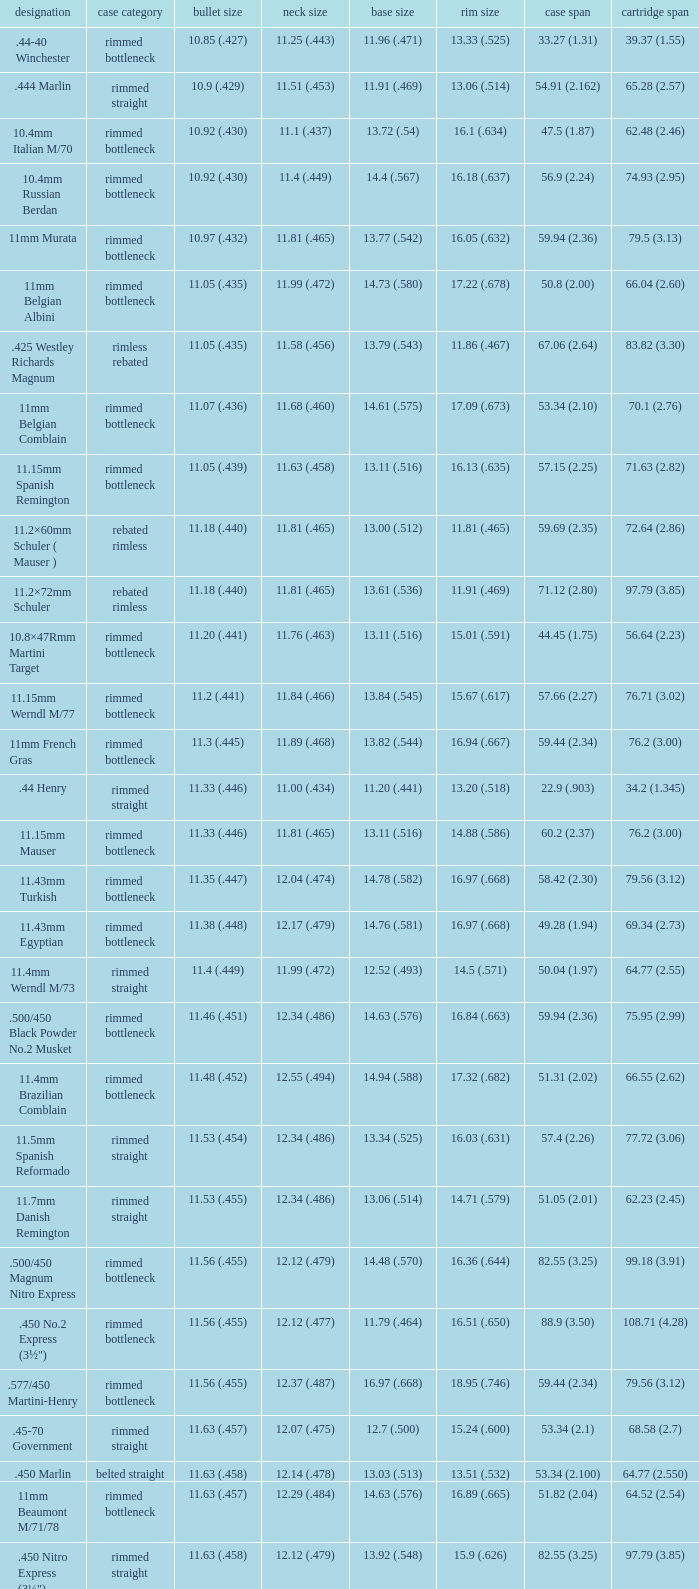Could you parse the entire table? {'header': ['designation', 'case category', 'bullet size', 'neck size', 'base size', 'rim size', 'case span', 'cartridge span'], 'rows': [['.44-40 Winchester', 'rimmed bottleneck', '10.85 (.427)', '11.25 (.443)', '11.96 (.471)', '13.33 (.525)', '33.27 (1.31)', '39.37 (1.55)'], ['.444 Marlin', 'rimmed straight', '10.9 (.429)', '11.51 (.453)', '11.91 (.469)', '13.06 (.514)', '54.91 (2.162)', '65.28 (2.57)'], ['10.4mm Italian M/70', 'rimmed bottleneck', '10.92 (.430)', '11.1 (.437)', '13.72 (.54)', '16.1 (.634)', '47.5 (1.87)', '62.48 (2.46)'], ['10.4mm Russian Berdan', 'rimmed bottleneck', '10.92 (.430)', '11.4 (.449)', '14.4 (.567)', '16.18 (.637)', '56.9 (2.24)', '74.93 (2.95)'], ['11mm Murata', 'rimmed bottleneck', '10.97 (.432)', '11.81 (.465)', '13.77 (.542)', '16.05 (.632)', '59.94 (2.36)', '79.5 (3.13)'], ['11mm Belgian Albini', 'rimmed bottleneck', '11.05 (.435)', '11.99 (.472)', '14.73 (.580)', '17.22 (.678)', '50.8 (2.00)', '66.04 (2.60)'], ['.425 Westley Richards Magnum', 'rimless rebated', '11.05 (.435)', '11.58 (.456)', '13.79 (.543)', '11.86 (.467)', '67.06 (2.64)', '83.82 (3.30)'], ['11mm Belgian Comblain', 'rimmed bottleneck', '11.07 (.436)', '11.68 (.460)', '14.61 (.575)', '17.09 (.673)', '53.34 (2.10)', '70.1 (2.76)'], ['11.15mm Spanish Remington', 'rimmed bottleneck', '11.05 (.439)', '11.63 (.458)', '13.11 (.516)', '16.13 (.635)', '57.15 (2.25)', '71.63 (2.82)'], ['11.2×60mm Schuler ( Mauser )', 'rebated rimless', '11.18 (.440)', '11.81 (.465)', '13.00 (.512)', '11.81 (.465)', '59.69 (2.35)', '72.64 (2.86)'], ['11.2×72mm Schuler', 'rebated rimless', '11.18 (.440)', '11.81 (.465)', '13.61 (.536)', '11.91 (.469)', '71.12 (2.80)', '97.79 (3.85)'], ['10.8×47Rmm Martini Target', 'rimmed bottleneck', '11.20 (.441)', '11.76 (.463)', '13.11 (.516)', '15.01 (.591)', '44.45 (1.75)', '56.64 (2.23)'], ['11.15mm Werndl M/77', 'rimmed bottleneck', '11.2 (.441)', '11.84 (.466)', '13.84 (.545)', '15.67 (.617)', '57.66 (2.27)', '76.71 (3.02)'], ['11mm French Gras', 'rimmed bottleneck', '11.3 (.445)', '11.89 (.468)', '13.82 (.544)', '16.94 (.667)', '59.44 (2.34)', '76.2 (3.00)'], ['.44 Henry', 'rimmed straight', '11.33 (.446)', '11.00 (.434)', '11.20 (.441)', '13.20 (.518)', '22.9 (.903)', '34.2 (1.345)'], ['11.15mm Mauser', 'rimmed bottleneck', '11.33 (.446)', '11.81 (.465)', '13.11 (.516)', '14.88 (.586)', '60.2 (2.37)', '76.2 (3.00)'], ['11.43mm Turkish', 'rimmed bottleneck', '11.35 (.447)', '12.04 (.474)', '14.78 (.582)', '16.97 (.668)', '58.42 (2.30)', '79.56 (3.12)'], ['11.43mm Egyptian', 'rimmed bottleneck', '11.38 (.448)', '12.17 (.479)', '14.76 (.581)', '16.97 (.668)', '49.28 (1.94)', '69.34 (2.73)'], ['11.4mm Werndl M/73', 'rimmed straight', '11.4 (.449)', '11.99 (.472)', '12.52 (.493)', '14.5 (.571)', '50.04 (1.97)', '64.77 (2.55)'], ['.500/450 Black Powder No.2 Musket', 'rimmed bottleneck', '11.46 (.451)', '12.34 (.486)', '14.63 (.576)', '16.84 (.663)', '59.94 (2.36)', '75.95 (2.99)'], ['11.4mm Brazilian Comblain', 'rimmed bottleneck', '11.48 (.452)', '12.55 (.494)', '14.94 (.588)', '17.32 (.682)', '51.31 (2.02)', '66.55 (2.62)'], ['11.5mm Spanish Reformado', 'rimmed straight', '11.53 (.454)', '12.34 (.486)', '13.34 (.525)', '16.03 (.631)', '57.4 (2.26)', '77.72 (3.06)'], ['11.7mm Danish Remington', 'rimmed straight', '11.53 (.455)', '12.34 (.486)', '13.06 (.514)', '14.71 (.579)', '51.05 (2.01)', '62.23 (2.45)'], ['.500/450 Magnum Nitro Express', 'rimmed bottleneck', '11.56 (.455)', '12.12 (.479)', '14.48 (.570)', '16.36 (.644)', '82.55 (3.25)', '99.18 (3.91)'], ['.450 No.2 Express (3½")', 'rimmed bottleneck', '11.56 (.455)', '12.12 (.477)', '11.79 (.464)', '16.51 (.650)', '88.9 (3.50)', '108.71 (4.28)'], ['.577/450 Martini-Henry', 'rimmed bottleneck', '11.56 (.455)', '12.37 (.487)', '16.97 (.668)', '18.95 (.746)', '59.44 (2.34)', '79.56 (3.12)'], ['.45-70 Government', 'rimmed straight', '11.63 (.457)', '12.07 (.475)', '12.7 (.500)', '15.24 (.600)', '53.34 (2.1)', '68.58 (2.7)'], ['.450 Marlin', 'belted straight', '11.63 (.458)', '12.14 (.478)', '13.03 (.513)', '13.51 (.532)', '53.34 (2.100)', '64.77 (2.550)'], ['11mm Beaumont M/71/78', 'rimmed bottleneck', '11.63 (.457)', '12.29 (.484)', '14.63 (.576)', '16.89 (.665)', '51.82 (2.04)', '64.52 (2.54)'], ['.450 Nitro Express (3¼")', 'rimmed straight', '11.63 (.458)', '12.12 (.479)', '13.92 (.548)', '15.9 (.626)', '82.55 (3.25)', '97.79 (3.85)'], ['.458 Winchester Magnum', 'belted straight', '11.63 (.458)', '12.14 (.478)', '13.03 (.513)', '13.51 (.532)', '63.5 (2.5)', '82.55 (3.350)'], ['.460 Weatherby Magnum', 'belted bottleneck', '11.63 (.458)', '12.32 (.485)', '14.80 (.583)', '13.54 (.533)', '74 (2.91)', '95.25 (3.75)'], ['.500/450 No.1 Express', 'rimmed bottleneck', '11.63 (.458)', '12.32 (.485)', '14.66 (.577)', '16.76 (.660)', '69.85 (2.75)', '82.55 (3.25)'], ['.450 Rigby Rimless', 'rimless bottleneck', '11.63 (.458)', '12.38 (.487)', '14.66 (.577)', '14.99 (.590)', '73.50 (2.89)', '95.00 (3.74)'], ['11.3mm Beaumont M/71', 'rimmed bottleneck', '11.63 (.464)', '12.34 (.486)', '14.76 (.581)', '16.92 (.666)', '50.04 (1.97)', '63.25 (2.49)'], ['.500/465 Nitro Express', 'rimmed bottleneck', '11.84 (.466)', '12.39 (.488)', '14.55 (.573)', '16.51 (.650)', '82.3 (3.24)', '98.04 (3.89)']]} Which Bullet diameter has a Name of 11.4mm werndl m/73? 11.4 (.449). 